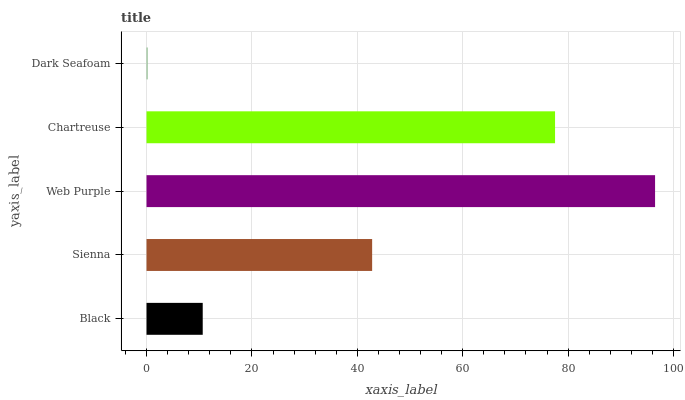Is Dark Seafoam the minimum?
Answer yes or no. Yes. Is Web Purple the maximum?
Answer yes or no. Yes. Is Sienna the minimum?
Answer yes or no. No. Is Sienna the maximum?
Answer yes or no. No. Is Sienna greater than Black?
Answer yes or no. Yes. Is Black less than Sienna?
Answer yes or no. Yes. Is Black greater than Sienna?
Answer yes or no. No. Is Sienna less than Black?
Answer yes or no. No. Is Sienna the high median?
Answer yes or no. Yes. Is Sienna the low median?
Answer yes or no. Yes. Is Chartreuse the high median?
Answer yes or no. No. Is Web Purple the low median?
Answer yes or no. No. 